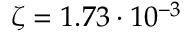Convert formula to latex. <formula><loc_0><loc_0><loc_500><loc_500>\zeta = 1 . 7 3 \cdot 1 0 ^ { - 3 }</formula> 